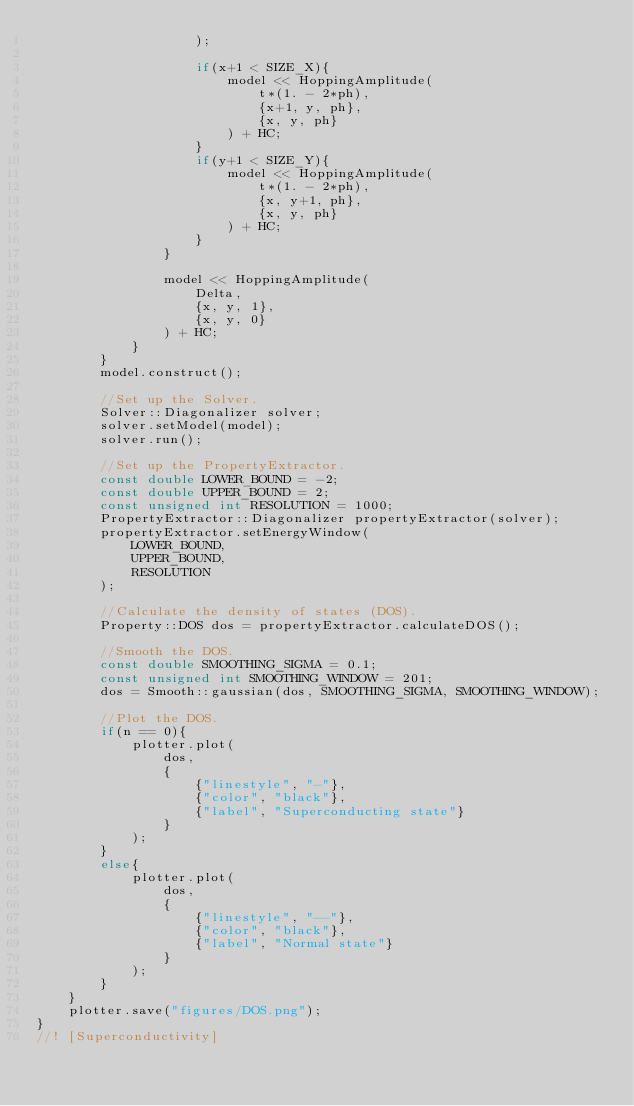<code> <loc_0><loc_0><loc_500><loc_500><_C++_>					);

					if(x+1 < SIZE_X){
						model << HoppingAmplitude(
							t*(1. - 2*ph),
							{x+1, y, ph},
							{x, y, ph}
						) + HC;
					}
					if(y+1 < SIZE_Y){
						model << HoppingAmplitude(
							t*(1. - 2*ph),
							{x, y+1, ph},
							{x, y, ph}
						) + HC;
					}
				}

				model << HoppingAmplitude(
					Delta,
					{x, y, 1},
					{x, y, 0}
				) + HC;
			}
		}
		model.construct();

		//Set up the Solver.
		Solver::Diagonalizer solver;
		solver.setModel(model);
		solver.run();

		//Set up the PropertyExtractor.
		const double LOWER_BOUND = -2;
		const double UPPER_BOUND = 2;
		const unsigned int RESOLUTION = 1000;
		PropertyExtractor::Diagonalizer propertyExtractor(solver);
		propertyExtractor.setEnergyWindow(
			LOWER_BOUND,
			UPPER_BOUND,
			RESOLUTION
		);

		//Calculate the density of states (DOS).
		Property::DOS dos = propertyExtractor.calculateDOS();

		//Smooth the DOS.
		const double SMOOTHING_SIGMA = 0.1;
		const unsigned int SMOOTHING_WINDOW = 201;
		dos = Smooth::gaussian(dos, SMOOTHING_SIGMA, SMOOTHING_WINDOW);

		//Plot the DOS.
		if(n == 0){
			plotter.plot(
				dos,
				{
					{"linestyle", "-"},
					{"color", "black"},
					{"label", "Superconducting state"}
				}
			);
		}
		else{
			plotter.plot(
				dos,
				{
					{"linestyle", "--"},
					{"color", "black"},
					{"label", "Normal state"}
				}
			);
		}
	}
	plotter.save("figures/DOS.png");
}
//! [Superconductivity]
</code> 